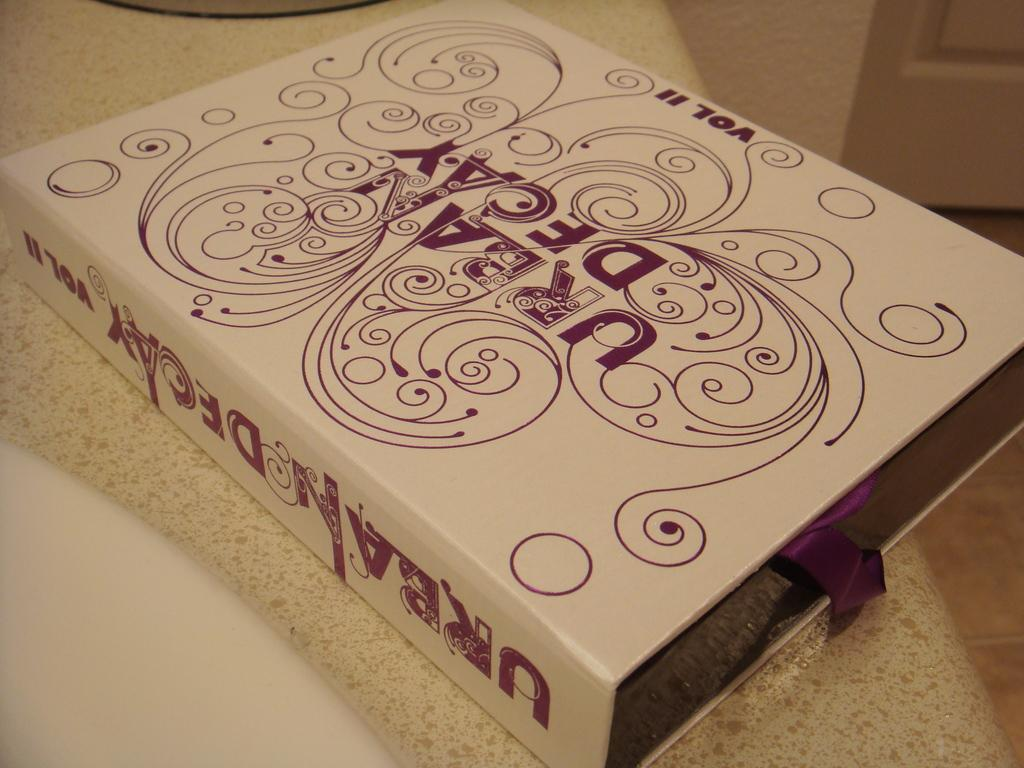<image>
Offer a succinct explanation of the picture presented. A box with an Urban Decay logo that is labeled as Volume II. 